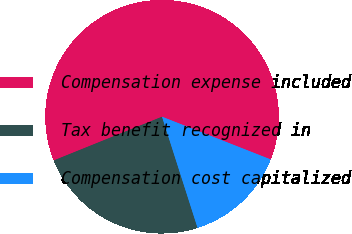Convert chart. <chart><loc_0><loc_0><loc_500><loc_500><pie_chart><fcel>Compensation expense included<fcel>Tax benefit recognized in<fcel>Compensation cost capitalized<nl><fcel>62.07%<fcel>23.82%<fcel>14.11%<nl></chart> 